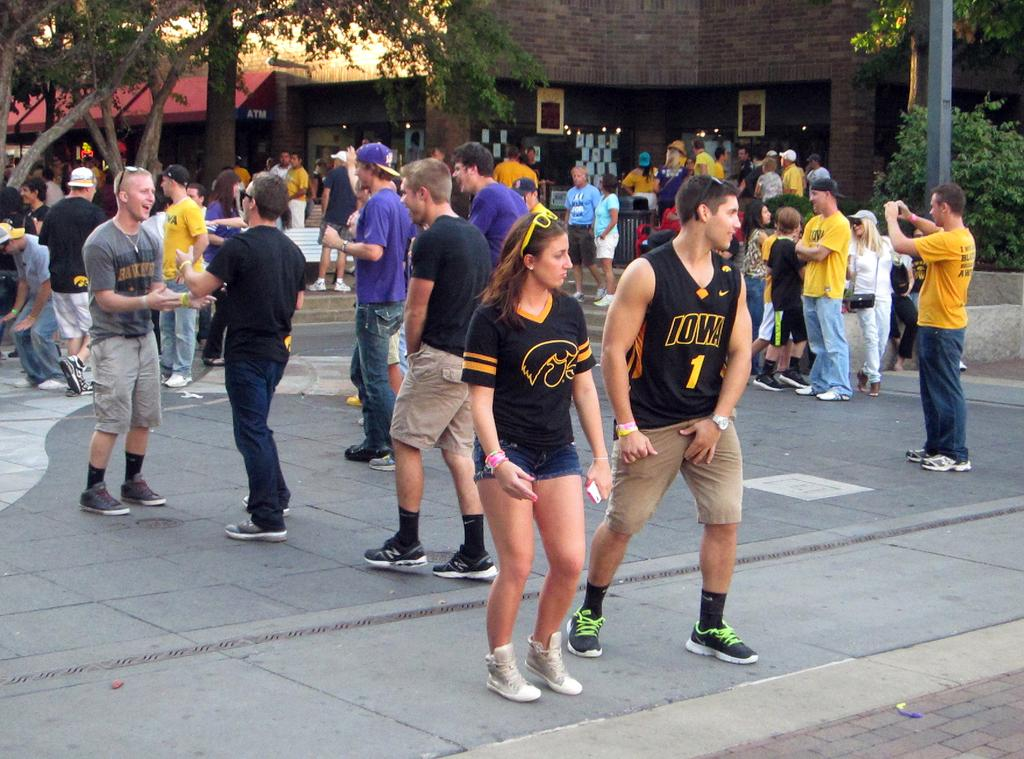What are the people in the image doing? There are people standing, walking, and talking in the image. What can be seen in the background of the image? There are plants, trees, and building walls in the background of the image. What month is it in the image? The month cannot be determined from the image, as there is no information about the time of year or any specific date. 